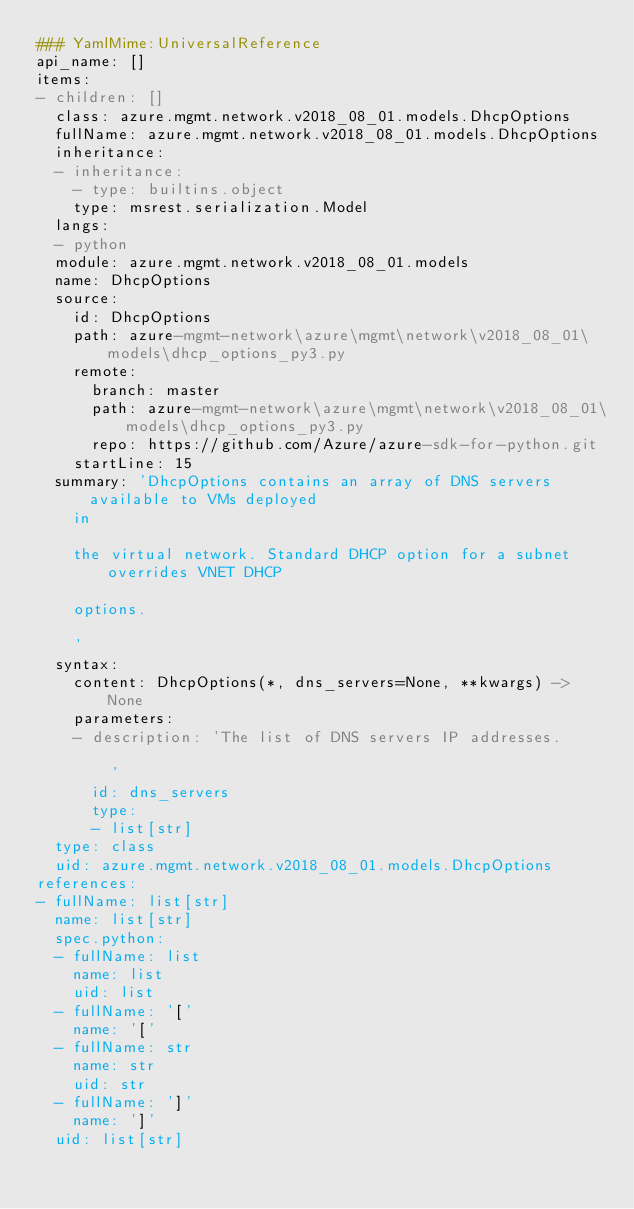Convert code to text. <code><loc_0><loc_0><loc_500><loc_500><_YAML_>### YamlMime:UniversalReference
api_name: []
items:
- children: []
  class: azure.mgmt.network.v2018_08_01.models.DhcpOptions
  fullName: azure.mgmt.network.v2018_08_01.models.DhcpOptions
  inheritance:
  - inheritance:
    - type: builtins.object
    type: msrest.serialization.Model
  langs:
  - python
  module: azure.mgmt.network.v2018_08_01.models
  name: DhcpOptions
  source:
    id: DhcpOptions
    path: azure-mgmt-network\azure\mgmt\network\v2018_08_01\models\dhcp_options_py3.py
    remote:
      branch: master
      path: azure-mgmt-network\azure\mgmt\network\v2018_08_01\models\dhcp_options_py3.py
      repo: https://github.com/Azure/azure-sdk-for-python.git
    startLine: 15
  summary: 'DhcpOptions contains an array of DNS servers available to VMs deployed
    in

    the virtual network. Standard DHCP option for a subnet overrides VNET DHCP

    options.

    '
  syntax:
    content: DhcpOptions(*, dns_servers=None, **kwargs) -> None
    parameters:
    - description: 'The list of DNS servers IP addresses.

        '
      id: dns_servers
      type:
      - list[str]
  type: class
  uid: azure.mgmt.network.v2018_08_01.models.DhcpOptions
references:
- fullName: list[str]
  name: list[str]
  spec.python:
  - fullName: list
    name: list
    uid: list
  - fullName: '['
    name: '['
  - fullName: str
    name: str
    uid: str
  - fullName: ']'
    name: ']'
  uid: list[str]
</code> 